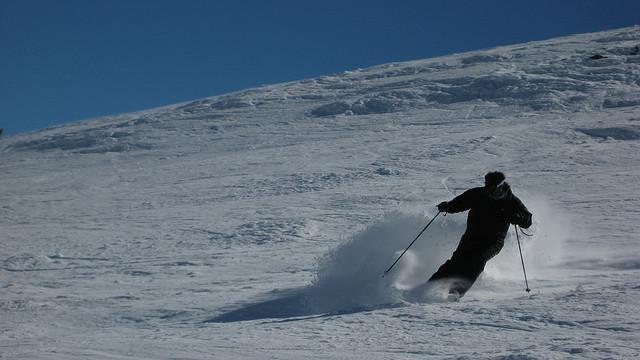How many laptops are in the photo?
Give a very brief answer. 0. 